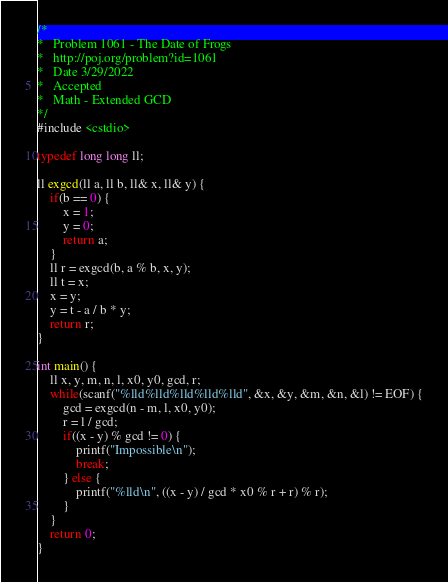<code> <loc_0><loc_0><loc_500><loc_500><_C++_>/*
*	Problem 1061 - The Date of Frogs
*	http://poj.org/problem?id=1061
*	Date 3/29/2022
*	Accepted
*	Math - Extended GCD
*/
#include <cstdio>

typedef long long ll;

ll exgcd(ll a, ll b, ll& x, ll& y) {
	if(b == 0) {
		x = 1;
		y = 0;
		return a;
	}
	ll r = exgcd(b, a % b, x, y);
	ll t = x;
	x = y;
	y = t - a / b * y;
	return r;
}

int main() {
	ll x, y, m, n, l, x0, y0, gcd, r;
	while(scanf("%lld%lld%lld%lld%lld", &x, &y, &m, &n, &l) != EOF) {
		gcd = exgcd(n - m, l, x0, y0);
		r = l / gcd;
		if((x - y) % gcd != 0) {
			printf("Impossible\n");
			break;
		} else {
			printf("%lld\n", ((x - y) / gcd * x0 % r + r) % r);
		}
	}
	return 0;
}
</code> 